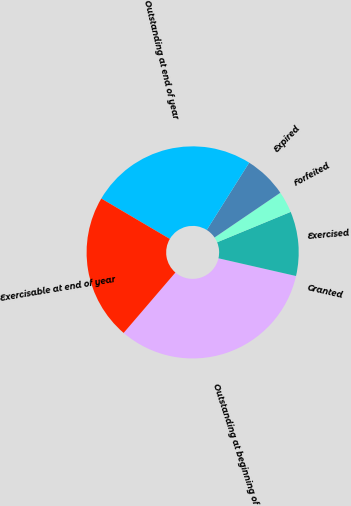Convert chart. <chart><loc_0><loc_0><loc_500><loc_500><pie_chart><fcel>Outstanding at beginning of<fcel>Granted<fcel>Exercised<fcel>Forfeited<fcel>Expired<fcel>Outstanding at end of year<fcel>Exercisable at end of year<nl><fcel>32.7%<fcel>0.0%<fcel>9.81%<fcel>3.27%<fcel>6.54%<fcel>25.47%<fcel>22.2%<nl></chart> 